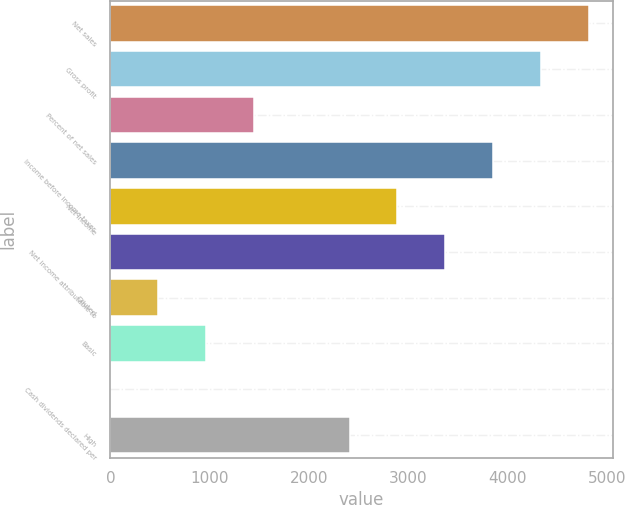<chart> <loc_0><loc_0><loc_500><loc_500><bar_chart><fcel>Net sales<fcel>Gross profit<fcel>Percent of net sales<fcel>Income before income taxes<fcel>Net income<fcel>Net income attributable to<fcel>Diluted<fcel>Basic<fcel>Cash dividends declared per<fcel>High<nl><fcel>4813<fcel>4331.73<fcel>1444.29<fcel>3850.49<fcel>2888.01<fcel>3369.25<fcel>481.81<fcel>963.05<fcel>0.57<fcel>2406.77<nl></chart> 